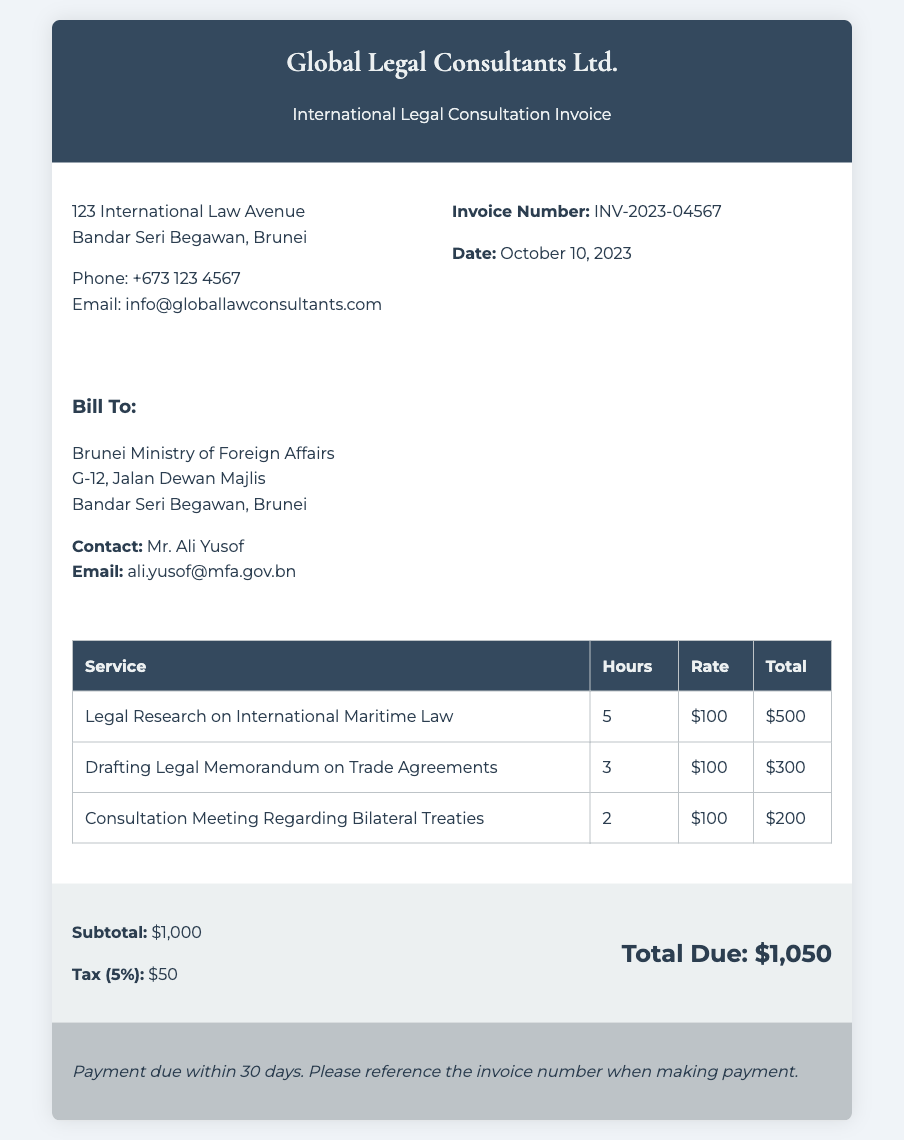What is the invoice number? The invoice number is listed in the document as a unique identifier for billing purposes.
Answer: INV-2023-04567 What is the hourly rate for services rendered? The hourly rate is shown in the body of the services table and is the same for all listed services.
Answer: $100 How many hours were spent on drafting the legal memorandum? The number of hours for each service is specified in the services table, showing the total hours dedicated to this task.
Answer: 3 What is the total due amount? The total due is calculated by adding the subtotal and tax, highlighted in the summary section of the document.
Answer: $1,050 What is the tax rate applied in this invoice? The tax rate is specified as a percentage in the summary section and applies to the subtotal amount.
Answer: 5% Who is the client for this invoice? The client for this legal consultation is mentioned in the document, providing the name and location.
Answer: Brunei Ministry of Foreign Affairs What is the date of the invoice? The date serves to indicate when the invoice was issued, which is important for payment tracking.
Answer: October 10, 2023 Which service required the most hours? The tasks are listed with their corresponding hours, helping to identify which service took the most time.
Answer: Legal Research on International Maritime Law What is the payment term stated in the invoice? The payment term outlines the conditions under which payment is expected and is crucial for understanding the timeline for payment.
Answer: Payment due within 30 days 